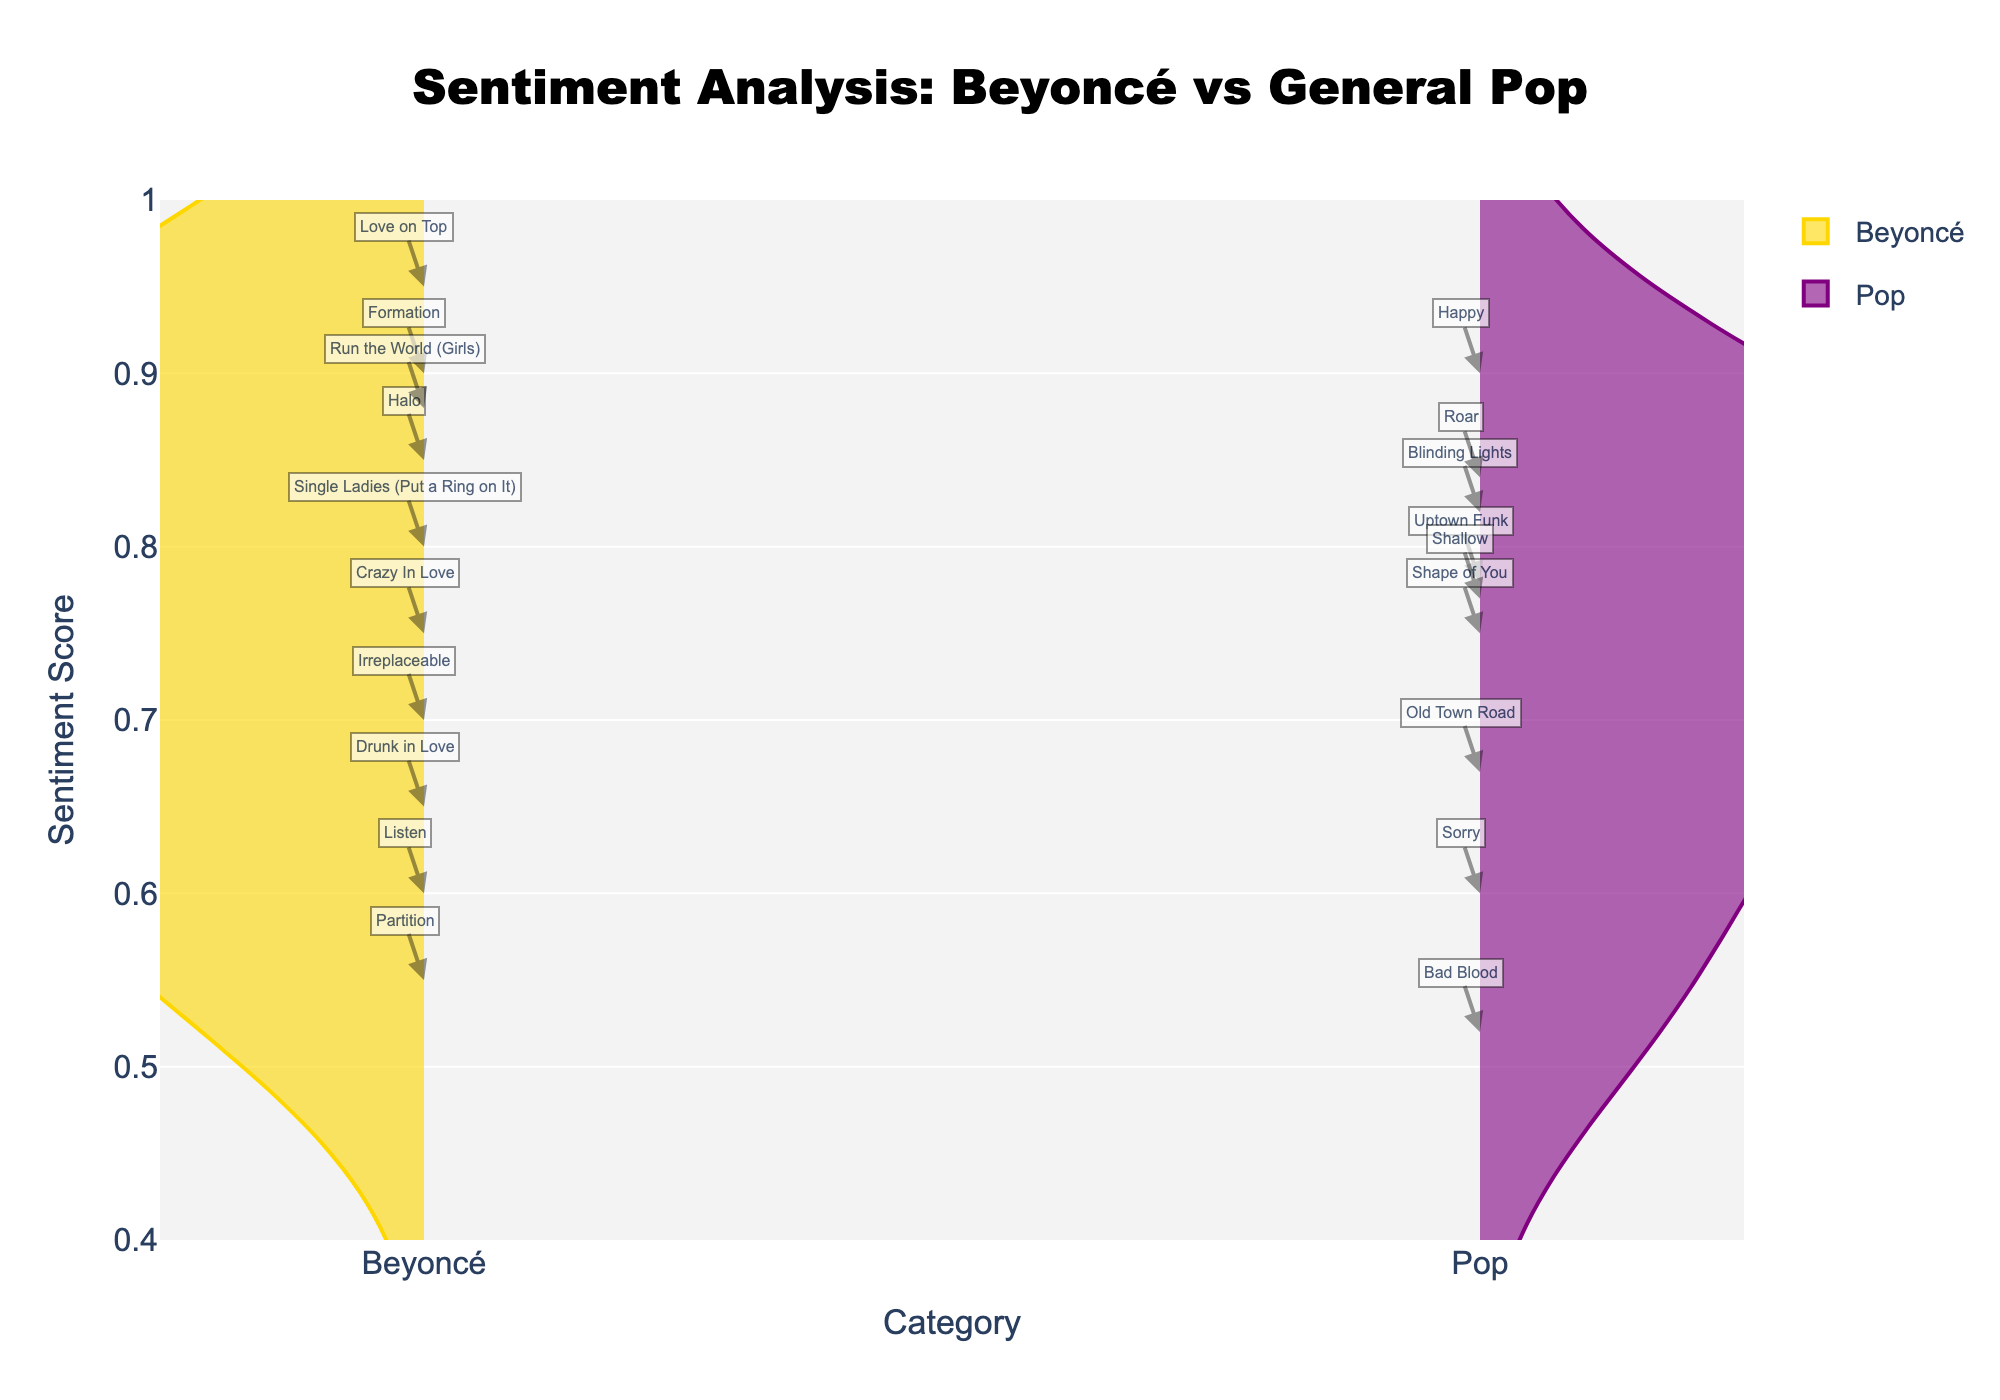How many categories are shown in the plot? There are two categories shown in the plot: "Beyoncé" and "Pop".
Answer: 2 What is the title of the plot? The title of the plot is "Sentiment Analysis: Beyoncé vs General Pop".
Answer: Sentiment Analysis: Beyoncé vs General Pop Which category has the maximum sentiment score? The maximum sentiment score is 0.95, which belongs to the Beyoncé category, indicated by the marker for "Love on Top".
Answer: Beyoncé What is the lowest sentiment score for Beyoncé's songs? The lowest sentiment score for Beyoncé's songs can be seen on the plot as 0.55 for the song "Partition".
Answer: 0.55 Do Beyoncé's songs have a higher median sentiment score compared to general pop songs? To find the median, arrange the sentiment scores in ascending order and find the middle value. Beyoncé scores: [0.55, 0.60, 0.65, 0.70, 0.75, 0.80, 0.85, 0.88, 0.90, 0.95], Median: 0.80. Pop scores: [0.52, 0.60, 0.67, 0.75, 0.77, 0.78, 0.82, 0.84, 0.90], Median: 0.77. Beyoncé's median is higher.
Answer: Yes Which sentiment score appears more spread out, Beyoncé's or Pop's? From the plot, the "Pop" sentiment scores appear more spread out compared to "Beyoncé", as they have a wider range on the violin plot.
Answer: Pop Is there any noticeable trend in sentiment scores for Beyoncé's songs versus Pop songs? Beyoncé's songs tend to have consistently high sentiment scores predominantly above 0.55 with many songs close to the top of the scale, while Pop songs have both high and lower sentiment scores with more variability.
Answer: Beyoncé's have higher and more consistent scores How does the sentiment score for "Run the World (Girls)" compare to "Happy"? The sentiment score for Beyoncé's "Run the World (Girls)" is 0.88, while for Pharrell Williams' "Happy" it's 0.90.
Answer: Happy is higher What is the average sentiment score of Beyoncé's songs? Sum all of Beyoncé's sentiment scores: 0.75 + 0.85 + 0.80 + 0.65 + 0.90 + 0.95 + 0.70 + 0.60 + 0.55 + 0.88 = 7.63. Divide by the number of songs: 7.63 / 10 = 0.763.
Answer: 0.763 